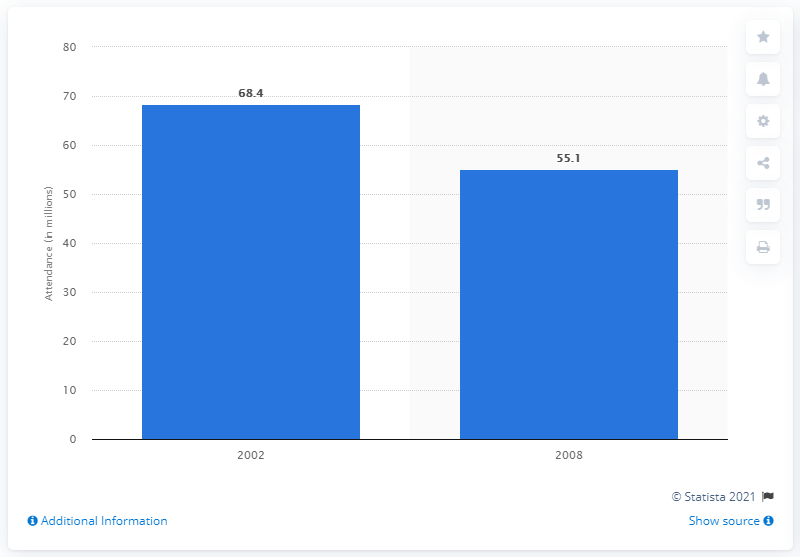Draw attention to some important aspects in this diagram. In 2002, approximately 68.4% of adults in the United States attended an art or craft fair or festival. 